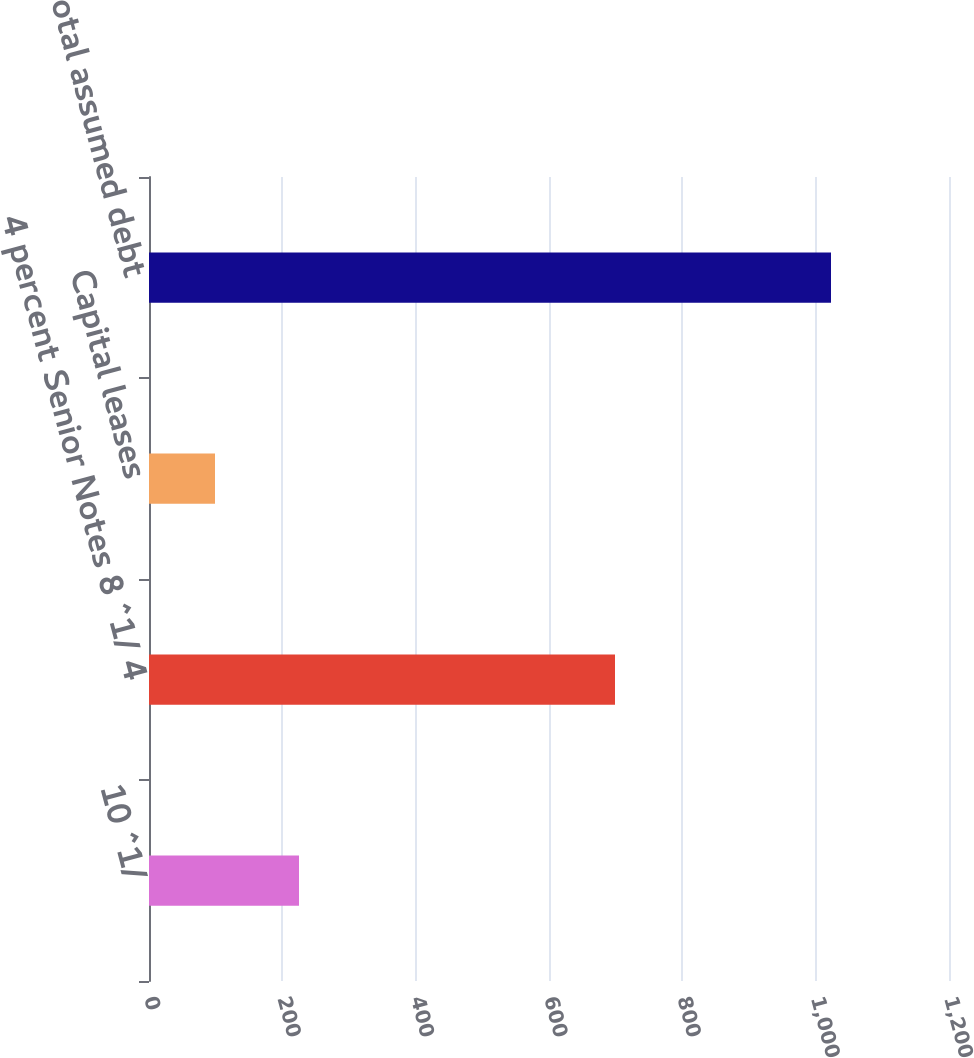<chart> <loc_0><loc_0><loc_500><loc_500><bar_chart><fcel>10 ^1/<fcel>4 percent Senior Notes 8 ^1/ 4<fcel>Capital leases<fcel>Total assumed debt<nl><fcel>225<fcel>699<fcel>99<fcel>1023<nl></chart> 